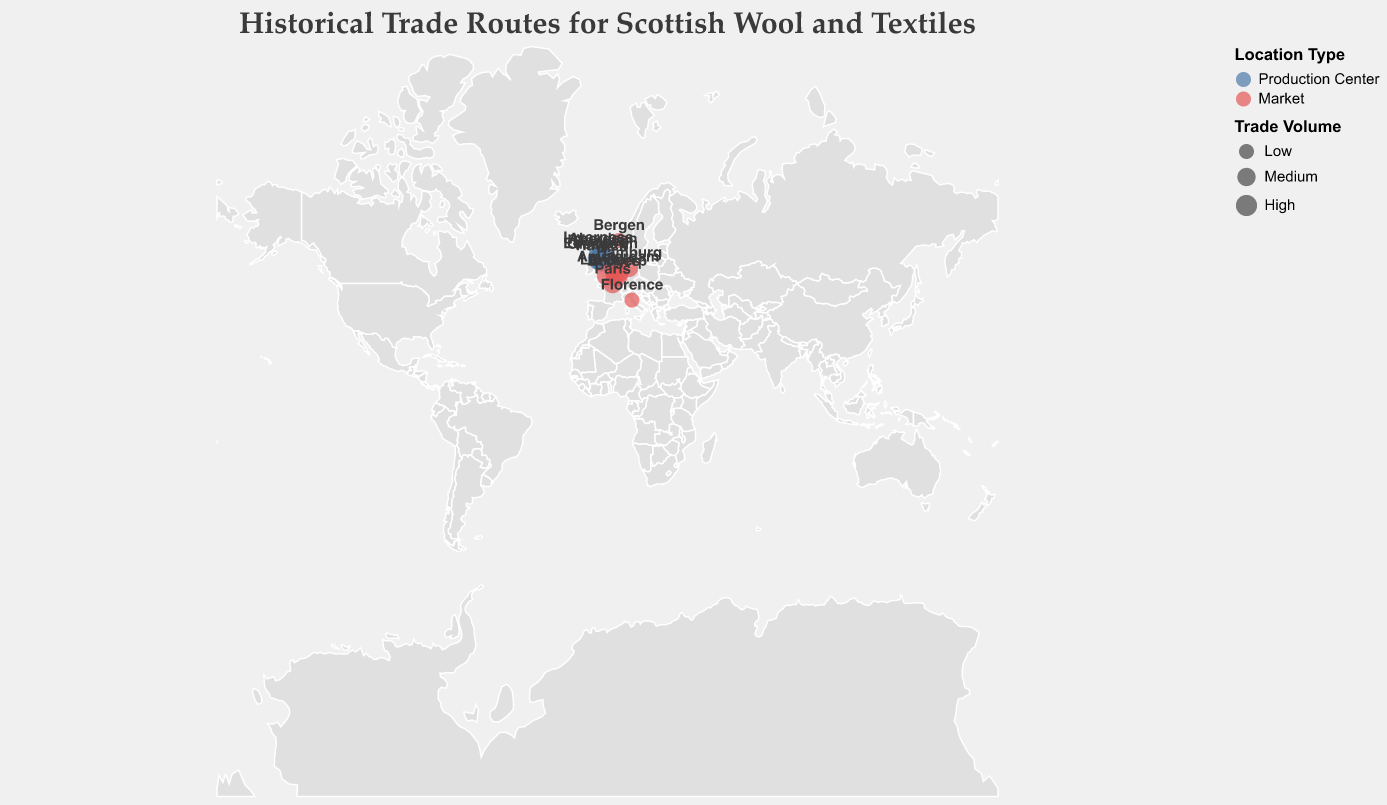What are the major production centers for Scottish wool and textiles? The major production centers are identified by the blue circles on the map. The locations labeled are Edinburgh, Glasgow, Aberdeen, Inverness, Hawick, and Dundee.
Answer: Edinburgh, Glasgow, Aberdeen, Inverness, Hawick, Dundee Which locations are marked as having high trade volumes? Locations with high trade volumes have larger circles. Both production centers (Edinburgh, Glasgow, Hawick) and markets (London, Amsterdam, Antwerp) show high trade volumes.
Answer: Edinburgh, Glasgow, Hawick, London, Amsterdam, Antwerp Which international market has the lowest trade volume, and where is it located? Looking for the smallest circles among the international markets, Bergen and Florence stand out. Their locations are also displayed as coordinates or names on the map.
Answer: Bergen, Florence How many international markets are shown on the plot? Counting all the red circles marked as "Market," we identify London, Amsterdam, Hamburg, Paris, Antwerp, Bergen, Bruges, and Florence.
Answer: 8 Which production center is northmost on the map? By examining the latitude values and the positions on the map, Inverness, located at a latitude of 57.4778, is the northernmost production center.
Answer: Inverness Compare the trade volumes of Glasgow and Hamburg. Which has a higher trade volume? Both locations are shown with different circle sizes. Glasgow's circle size is high, while Hamburg's circle size is medium.
Answer: Glasgow What is the latitude and longitude of the market with medium trade volume closest to the production center in Dundee? Identifying the medium trade volume markets near Dundee, Bruges in Belgium is the closest identified by its coordinates 51.2093, 3.2247.
Answer: Bruges (51.2093, 3.2247) Which locations on the plot are categorized as both production centers and high trade volume? Identifying the locations marked with blue circles and large sizes as high trade volume includes Edinburgh, Glasgow, and Hawick.
Answer: Edinburgh, Glasgow, Hawick 